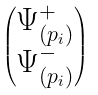<formula> <loc_0><loc_0><loc_500><loc_500>\begin{pmatrix} \Psi _ { ( p _ { i } ) } ^ { + } \\ \Psi _ { ( p _ { i } ) } ^ { - } \end{pmatrix}</formula> 